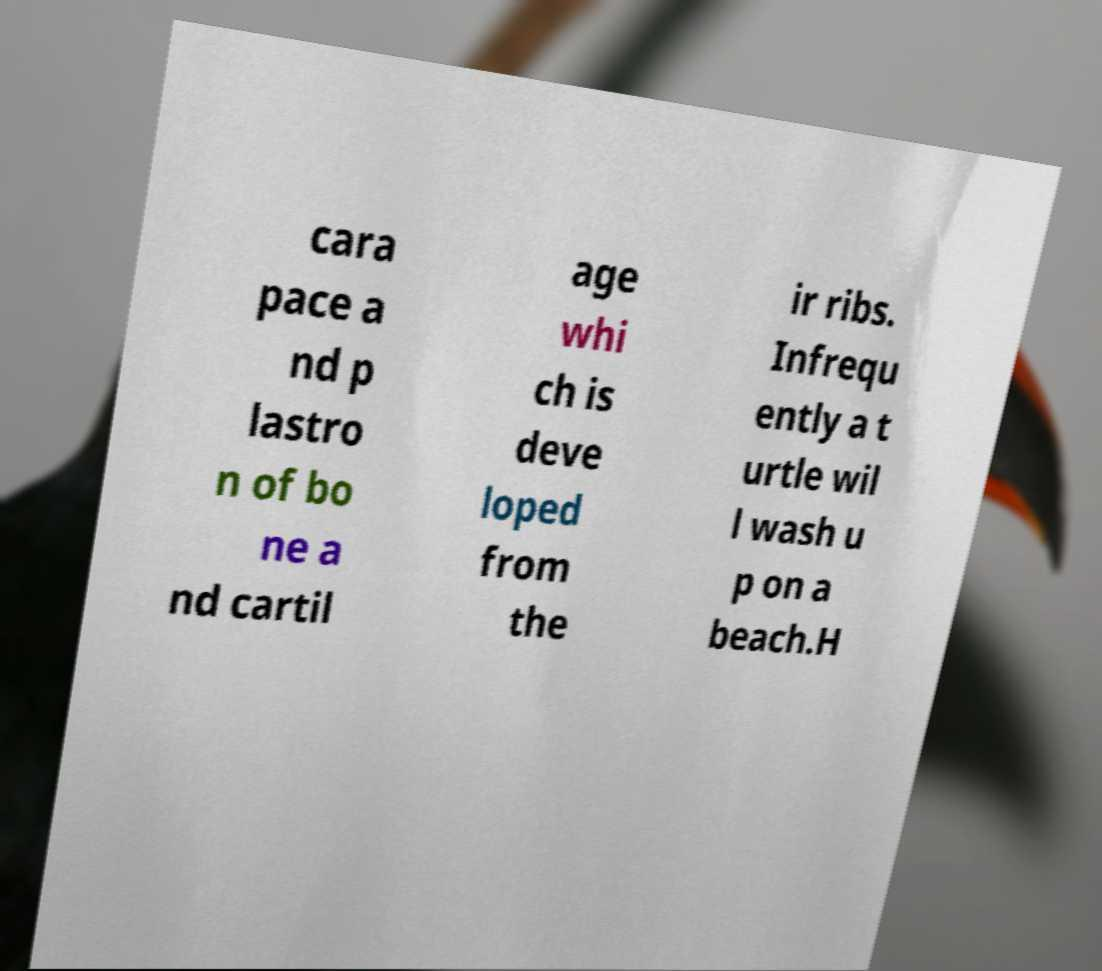Could you assist in decoding the text presented in this image and type it out clearly? cara pace a nd p lastro n of bo ne a nd cartil age whi ch is deve loped from the ir ribs. Infrequ ently a t urtle wil l wash u p on a beach.H 